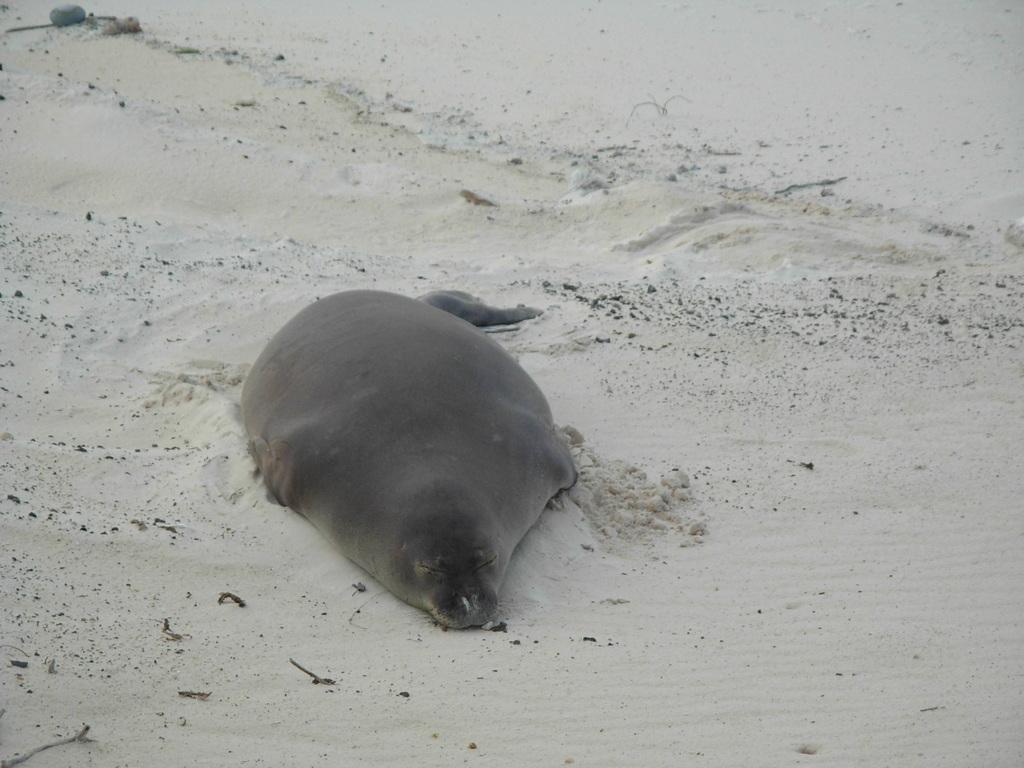What animal can be seen in the image? There is a seal in the image. What is the position of the seal in the image? The seal is lying on the ground. What type of surface is visible at the bottom of the image? There is white sand at the bottom of the image. What type of berry is the seal holding in its mouth in the image? There is no berry present in the image, and the seal is not holding anything in its mouth. 